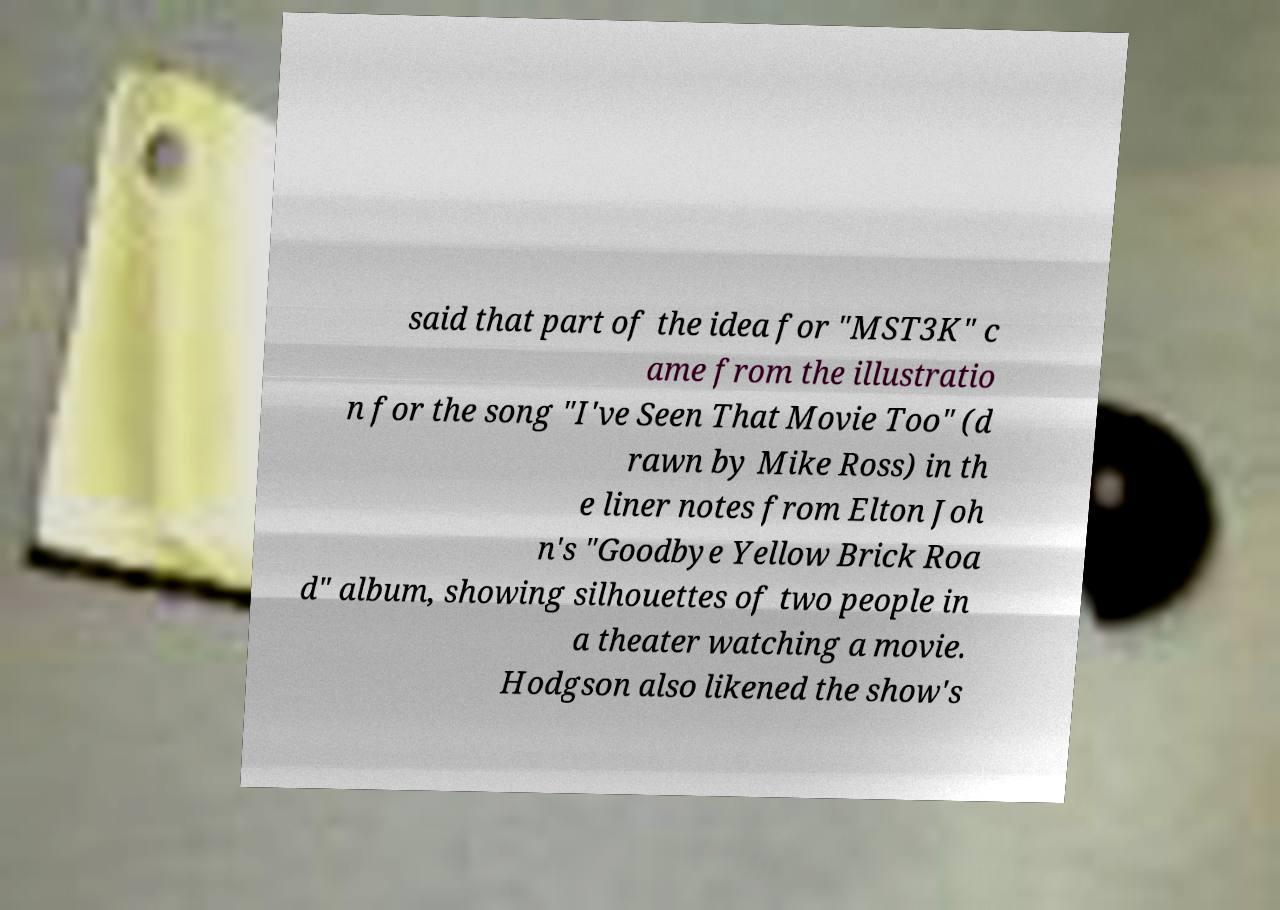For documentation purposes, I need the text within this image transcribed. Could you provide that? said that part of the idea for "MST3K" c ame from the illustratio n for the song "I've Seen That Movie Too" (d rawn by Mike Ross) in th e liner notes from Elton Joh n's "Goodbye Yellow Brick Roa d" album, showing silhouettes of two people in a theater watching a movie. Hodgson also likened the show's 